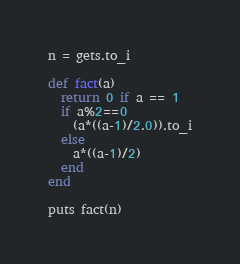<code> <loc_0><loc_0><loc_500><loc_500><_Ruby_>n = gets.to_i

def fact(a)
  return 0 if a == 1
  if a%2==0
    (a*((a-1)/2.0)).to_i
  else
    a*((a-1)/2)
  end
end

puts fact(n)

</code> 